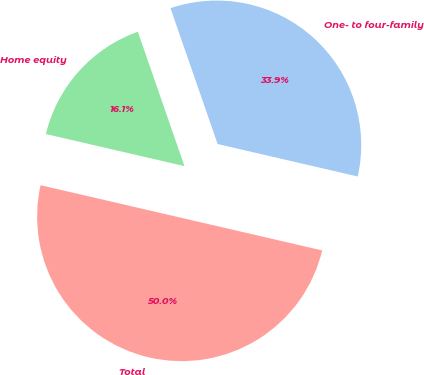Convert chart. <chart><loc_0><loc_0><loc_500><loc_500><pie_chart><fcel>One- to four-family<fcel>Home equity<fcel>Total<nl><fcel>33.94%<fcel>16.06%<fcel>50.0%<nl></chart> 